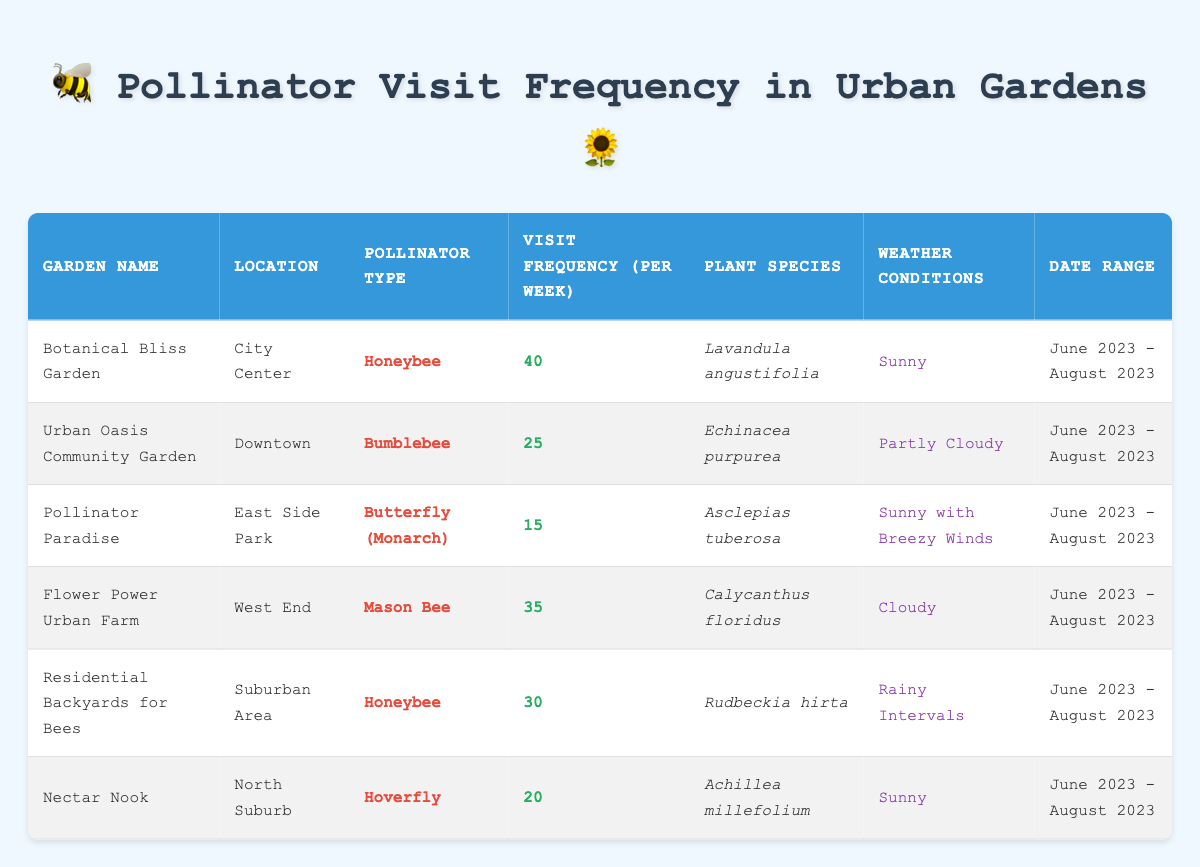What's the visit frequency of honeybees in urban gardens? There are two gardens with honeybees listed in the table: Botanical Bliss Garden with a visit frequency of 40 and Residential Backyards for Bees with a frequency of 30. The question asks for the visit frequency, so we can reference these values directly.
Answer: 40 and 30 Which garden has the highest visit frequency? By scanning the visit frequencies listed in the table, the highest visit frequency is 40, found at Botanical Bliss Garden. Thus, it is the garden with the highest frequency.
Answer: Botanical Bliss Garden What type of pollinator visits the Pollinator Paradise garden? The table indicates that Pollinator Paradise is visited by Monarch butterflies, as specified in the "Pollinator Type" column for that garden.
Answer: Butterfly (Monarch) What is the total visit frequency for all gardens listed? To find the total, sum up the visit frequencies for all gardens: 40 + 25 + 15 + 35 + 30 + 20 = 165. This gives us the overall visit frequency across all gardens.
Answer: 165 What plant species is associated with the bumblebee in the Urban Oasis Community Garden? The table states that the Urban Oasis Community Garden, where bumblebees visit, has Echinacea purpurea as its associated plant species. This directly references the plant species column for that garden.
Answer: Echinacea purpurea Are there any gardens categorized as experiencing rainy weather conditions? Checking the weather conditions for each garden, Residential Backyards for Bees is the only one noted with "Rainy Intervals." Thus, we conclude that there is indeed a garden with rainy weather conditions.
Answer: Yes What is the average visit frequency across the gardens listed? There are six gardens in total, with visit frequencies of 40, 25, 15, 35, 30, and 20. First, sum these values: 40 + 25 + 15 + 35 + 30 + 20 = 165, then divide by the number of gardens: 165/6 = 27.5. This gives us the average visit frequency across all gardens.
Answer: 27.5 Which garden has the least visit frequency, and what is that frequency? Scanning through the visit frequencies, Pollinator Paradise has the least with a visit frequency of 15. This is the lowest value reflected in the table.
Answer: Pollinator Paradise, 15 How many more visits do honeybees receive compared to butterflies? Honeybees in the Botanical Bliss Garden have 40 visits, and Monarch butterflies in Pollinator Paradise have 15 visits. The difference is calculated by subtracting the frequency of butterflies from honeybees: 40 - 15 = 25. Therefore, honeybees receive 25 more visits than butterflies.
Answer: 25 Is it true that all gardens experience sunny weather conditions? By reviewing the weather conditions for each garden, it is clear that not all gardens experience sunny weather; some are listed as "Partly Cloudy," "Cloudy," or "Rainy Intervals." Therefore, the statement is false.
Answer: No 